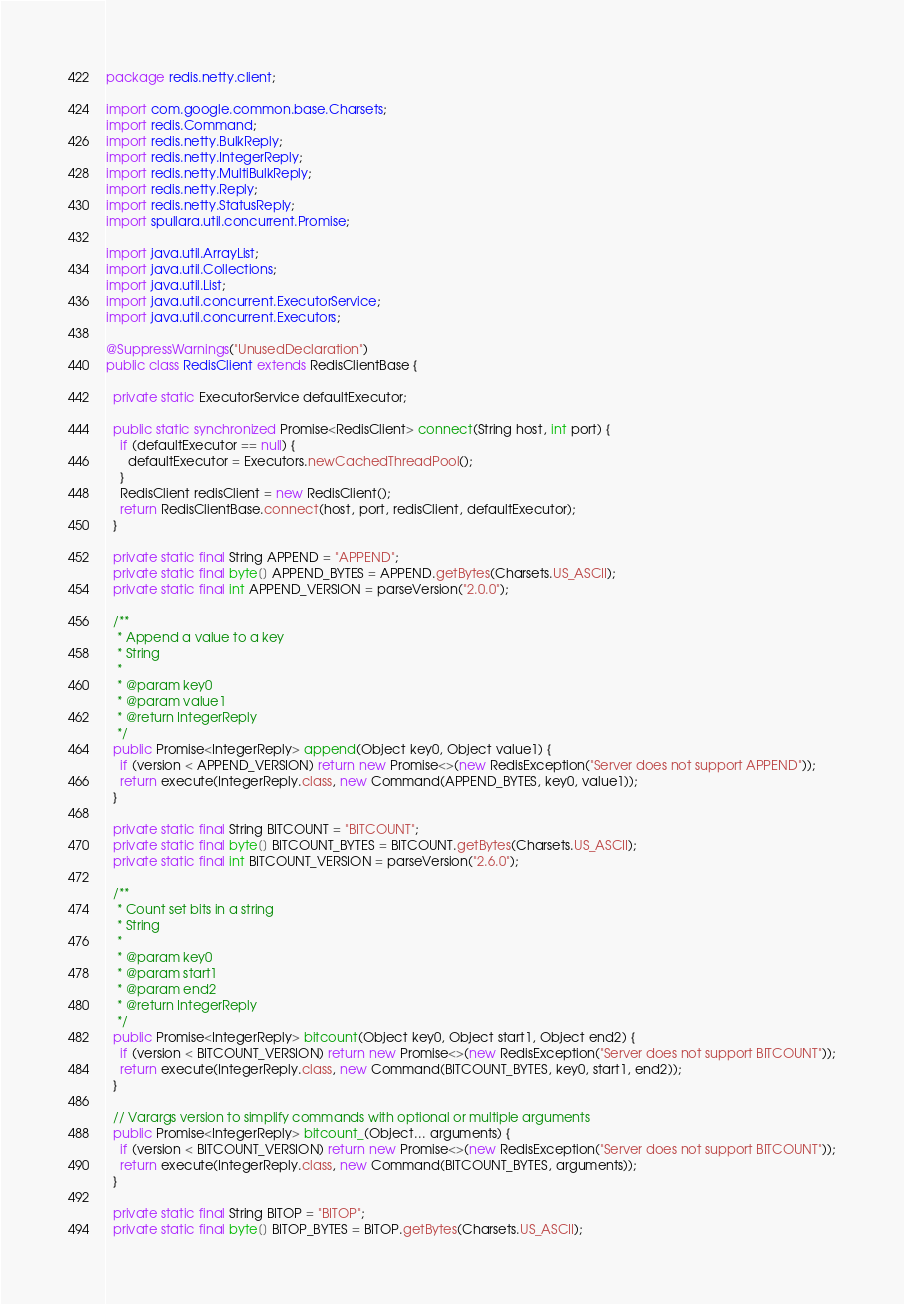<code> <loc_0><loc_0><loc_500><loc_500><_Java_>package redis.netty.client;

import com.google.common.base.Charsets;
import redis.Command;
import redis.netty.BulkReply;
import redis.netty.IntegerReply;
import redis.netty.MultiBulkReply;
import redis.netty.Reply;
import redis.netty.StatusReply;
import spullara.util.concurrent.Promise;

import java.util.ArrayList;
import java.util.Collections;
import java.util.List;
import java.util.concurrent.ExecutorService;
import java.util.concurrent.Executors;

@SuppressWarnings("UnusedDeclaration")
public class RedisClient extends RedisClientBase {

  private static ExecutorService defaultExecutor;

  public static synchronized Promise<RedisClient> connect(String host, int port) {
    if (defaultExecutor == null) {
      defaultExecutor = Executors.newCachedThreadPool();
    }
    RedisClient redisClient = new RedisClient();
    return RedisClientBase.connect(host, port, redisClient, defaultExecutor);
  }

  private static final String APPEND = "APPEND";
  private static final byte[] APPEND_BYTES = APPEND.getBytes(Charsets.US_ASCII);
  private static final int APPEND_VERSION = parseVersion("2.0.0");

  /**
   * Append a value to a key
   * String
   *
   * @param key0
   * @param value1
   * @return IntegerReply
   */
  public Promise<IntegerReply> append(Object key0, Object value1) {
    if (version < APPEND_VERSION) return new Promise<>(new RedisException("Server does not support APPEND"));
    return execute(IntegerReply.class, new Command(APPEND_BYTES, key0, value1));
  }

  private static final String BITCOUNT = "BITCOUNT";
  private static final byte[] BITCOUNT_BYTES = BITCOUNT.getBytes(Charsets.US_ASCII);
  private static final int BITCOUNT_VERSION = parseVersion("2.6.0");

  /**
   * Count set bits in a string
   * String
   *
   * @param key0
   * @param start1
   * @param end2
   * @return IntegerReply
   */
  public Promise<IntegerReply> bitcount(Object key0, Object start1, Object end2) {
    if (version < BITCOUNT_VERSION) return new Promise<>(new RedisException("Server does not support BITCOUNT"));
    return execute(IntegerReply.class, new Command(BITCOUNT_BYTES, key0, start1, end2));
  }

  // Varargs version to simplify commands with optional or multiple arguments
  public Promise<IntegerReply> bitcount_(Object... arguments) {
    if (version < BITCOUNT_VERSION) return new Promise<>(new RedisException("Server does not support BITCOUNT"));
    return execute(IntegerReply.class, new Command(BITCOUNT_BYTES, arguments));
  }

  private static final String BITOP = "BITOP";
  private static final byte[] BITOP_BYTES = BITOP.getBytes(Charsets.US_ASCII);</code> 